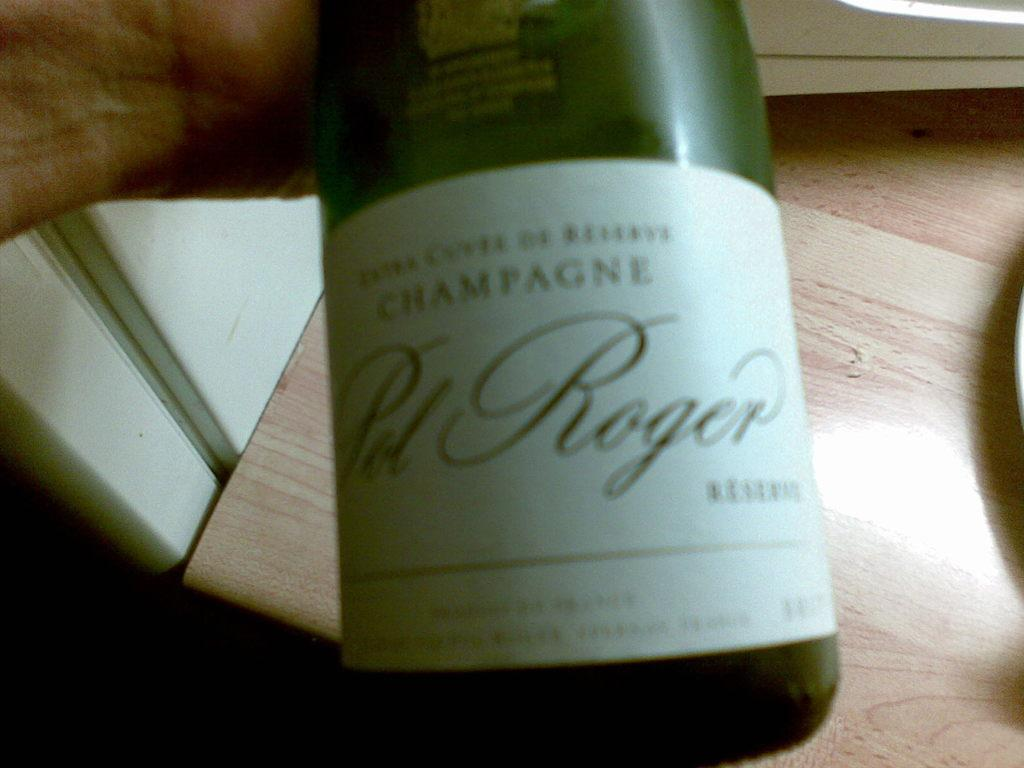<image>
Share a concise interpretation of the image provided. A bottle of Champagne is being held over a wood table. 